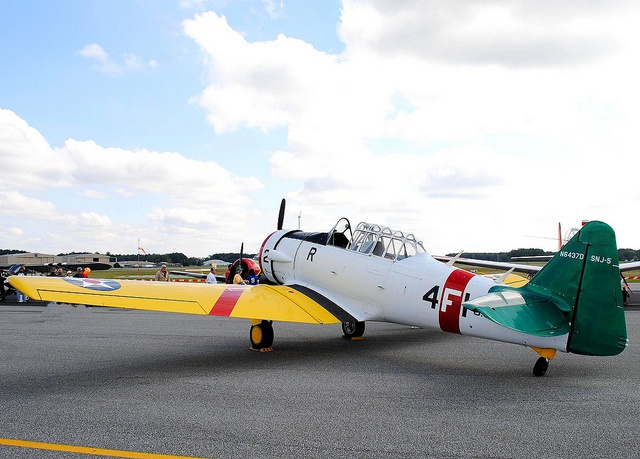Describe the objects in this image and their specific colors. I can see airplane in lightblue, black, darkgray, lightgray, and teal tones, airplane in lightblue, black, darkgray, brown, and lightpink tones, airplane in lightblue, lightgray, black, gray, and darkgray tones, people in lightblue, gray, tan, and darkgray tones, and people in lightblue, tan, black, and gray tones in this image. 